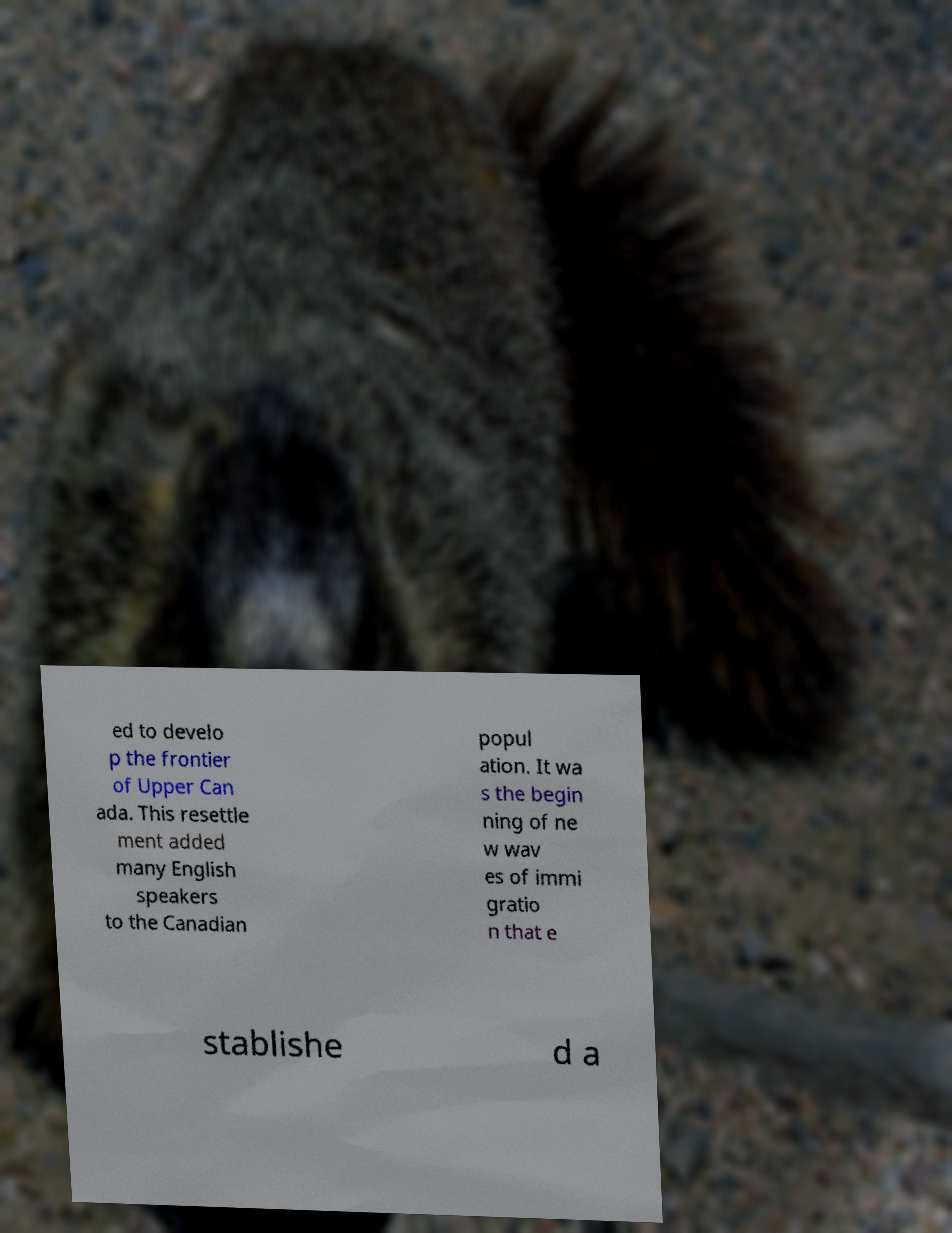Please identify and transcribe the text found in this image. ed to develo p the frontier of Upper Can ada. This resettle ment added many English speakers to the Canadian popul ation. It wa s the begin ning of ne w wav es of immi gratio n that e stablishe d a 